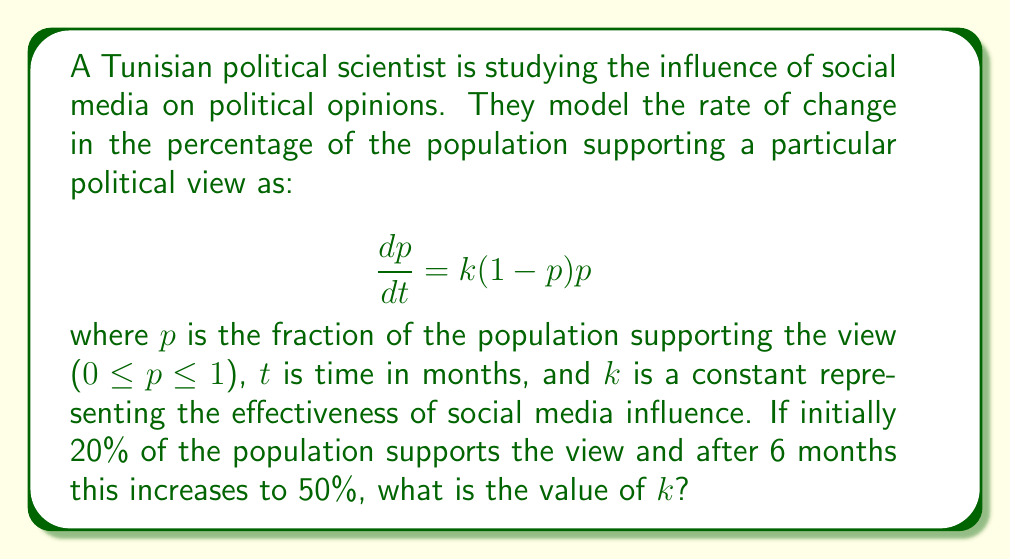Can you answer this question? To solve this problem, we need to follow these steps:

1) First, we recognize this as a logistic differential equation. The solution to this equation is:

   $$p(t) = \frac{1}{1 + Ce^{-kt}}$$

   where $C$ is a constant we need to determine.

2) We're given two conditions:
   At $t=0$, $p=0.2$
   At $t=6$, $p=0.5$

3) Let's use the initial condition to find $C$:
   
   $$0.2 = \frac{1}{1 + C}$$
   
   $$1 + C = \frac{1}{0.2} = 5$$
   
   $$C = 4$$

4) Now we can use the condition at $t=6$ to find $k$:

   $$0.5 = \frac{1}{1 + 4e^{-6k}}$$

5) Solving for $k$:

   $$2 = 1 + 4e^{-6k}$$
   $$1 = 4e^{-6k}$$
   $$\frac{1}{4} = e^{-6k}$$
   $$\ln(\frac{1}{4}) = -6k$$
   $$-\ln(4) = -6k$$
   $$\frac{\ln(4)}{6} = k$$

6) Calculate the final value:

   $$k = \frac{\ln(4)}{6} \approx 0.2310$$
Answer: $k \approx 0.2310$ per month 